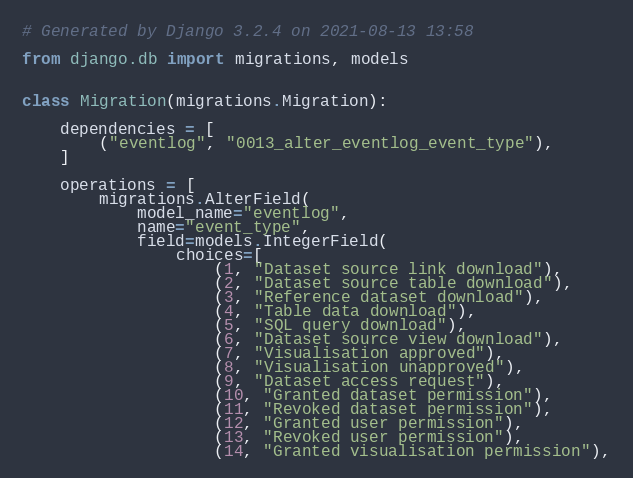<code> <loc_0><loc_0><loc_500><loc_500><_Python_># Generated by Django 3.2.4 on 2021-08-13 13:58

from django.db import migrations, models


class Migration(migrations.Migration):

    dependencies = [
        ("eventlog", "0013_alter_eventlog_event_type"),
    ]

    operations = [
        migrations.AlterField(
            model_name="eventlog",
            name="event_type",
            field=models.IntegerField(
                choices=[
                    (1, "Dataset source link download"),
                    (2, "Dataset source table download"),
                    (3, "Reference dataset download"),
                    (4, "Table data download"),
                    (5, "SQL query download"),
                    (6, "Dataset source view download"),
                    (7, "Visualisation approved"),
                    (8, "Visualisation unapproved"),
                    (9, "Dataset access request"),
                    (10, "Granted dataset permission"),
                    (11, "Revoked dataset permission"),
                    (12, "Granted user permission"),
                    (13, "Revoked user permission"),
                    (14, "Granted visualisation permission"),</code> 